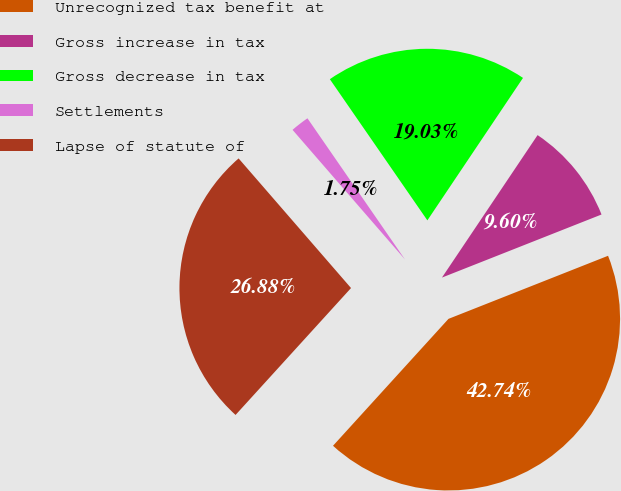Convert chart. <chart><loc_0><loc_0><loc_500><loc_500><pie_chart><fcel>Unrecognized tax benefit at<fcel>Gross increase in tax<fcel>Gross decrease in tax<fcel>Settlements<fcel>Lapse of statute of<nl><fcel>42.74%<fcel>9.6%<fcel>19.03%<fcel>1.75%<fcel>26.88%<nl></chart> 